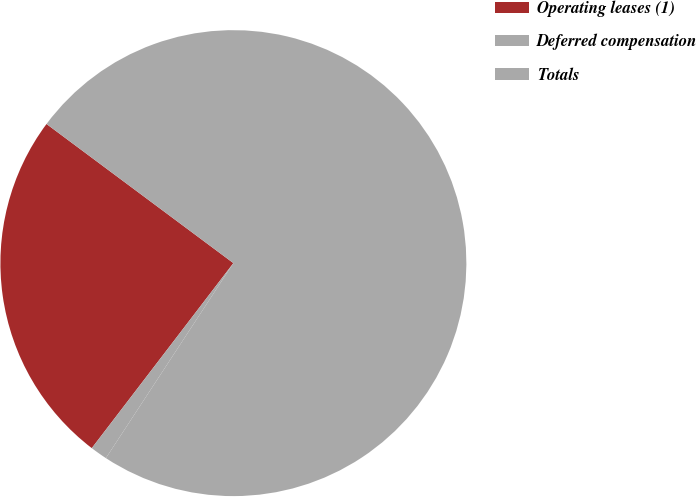Convert chart to OTSL. <chart><loc_0><loc_0><loc_500><loc_500><pie_chart><fcel>Operating leases (1)<fcel>Deferred compensation<fcel>Totals<nl><fcel>24.79%<fcel>1.18%<fcel>74.03%<nl></chart> 